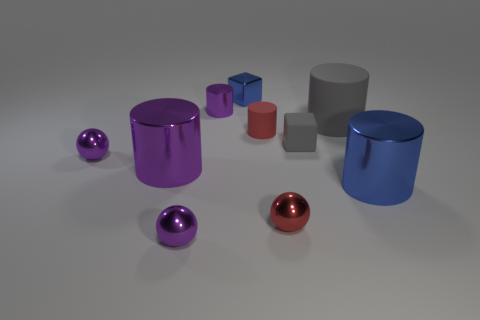Subtract all small cylinders. How many cylinders are left? 3 Subtract all gray cubes. How many purple cylinders are left? 2 Subtract all gray cubes. How many cubes are left? 1 Subtract all blocks. How many objects are left? 8 Subtract 3 balls. How many balls are left? 0 Subtract all cyan cubes. Subtract all purple spheres. How many cubes are left? 2 Subtract all big blue matte spheres. Subtract all purple shiny balls. How many objects are left? 8 Add 2 tiny red matte objects. How many tiny red matte objects are left? 3 Add 8 green metal cylinders. How many green metal cylinders exist? 8 Subtract 1 blue cylinders. How many objects are left? 9 